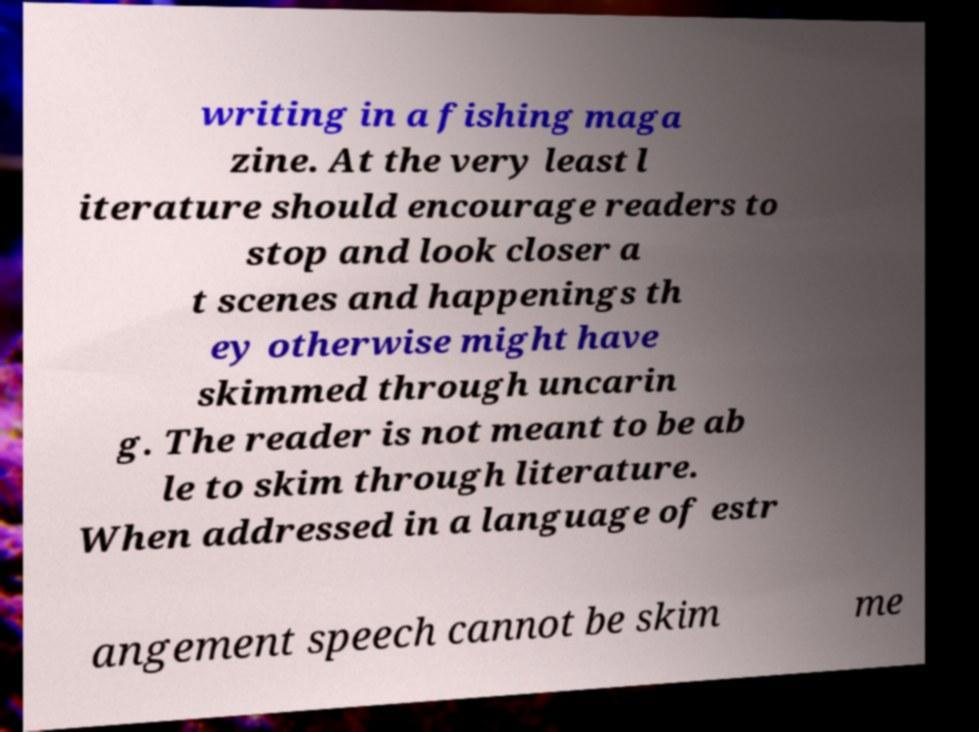Please read and relay the text visible in this image. What does it say? writing in a fishing maga zine. At the very least l iterature should encourage readers to stop and look closer a t scenes and happenings th ey otherwise might have skimmed through uncarin g. The reader is not meant to be ab le to skim through literature. When addressed in a language of estr angement speech cannot be skim me 